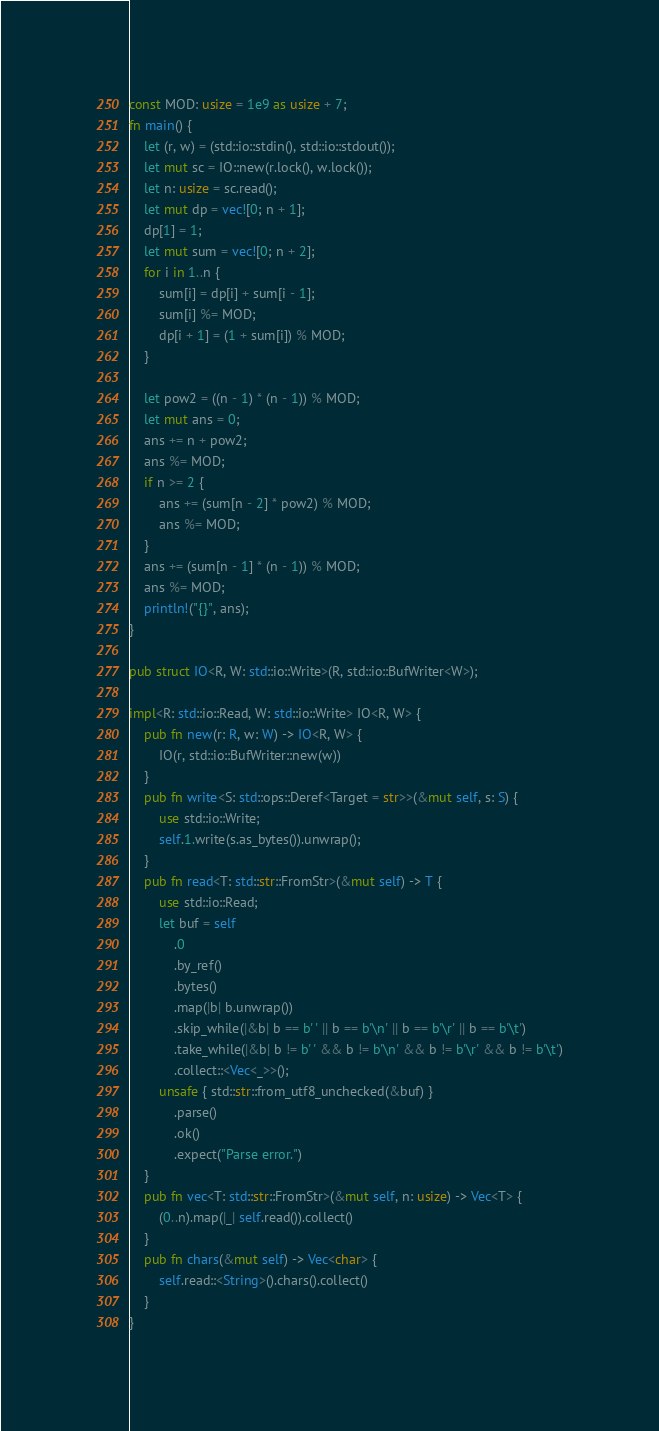<code> <loc_0><loc_0><loc_500><loc_500><_Rust_>const MOD: usize = 1e9 as usize + 7;
fn main() {
    let (r, w) = (std::io::stdin(), std::io::stdout());
    let mut sc = IO::new(r.lock(), w.lock());
    let n: usize = sc.read();
    let mut dp = vec![0; n + 1];
    dp[1] = 1;
    let mut sum = vec![0; n + 2];
    for i in 1..n {
        sum[i] = dp[i] + sum[i - 1];
        sum[i] %= MOD;
        dp[i + 1] = (1 + sum[i]) % MOD;
    }

    let pow2 = ((n - 1) * (n - 1)) % MOD;
    let mut ans = 0;
    ans += n + pow2;
    ans %= MOD;
    if n >= 2 {
        ans += (sum[n - 2] * pow2) % MOD;
        ans %= MOD;
    }
    ans += (sum[n - 1] * (n - 1)) % MOD;
    ans %= MOD;
    println!("{}", ans);
}

pub struct IO<R, W: std::io::Write>(R, std::io::BufWriter<W>);

impl<R: std::io::Read, W: std::io::Write> IO<R, W> {
    pub fn new(r: R, w: W) -> IO<R, W> {
        IO(r, std::io::BufWriter::new(w))
    }
    pub fn write<S: std::ops::Deref<Target = str>>(&mut self, s: S) {
        use std::io::Write;
        self.1.write(s.as_bytes()).unwrap();
    }
    pub fn read<T: std::str::FromStr>(&mut self) -> T {
        use std::io::Read;
        let buf = self
            .0
            .by_ref()
            .bytes()
            .map(|b| b.unwrap())
            .skip_while(|&b| b == b' ' || b == b'\n' || b == b'\r' || b == b'\t')
            .take_while(|&b| b != b' ' && b != b'\n' && b != b'\r' && b != b'\t')
            .collect::<Vec<_>>();
        unsafe { std::str::from_utf8_unchecked(&buf) }
            .parse()
            .ok()
            .expect("Parse error.")
    }
    pub fn vec<T: std::str::FromStr>(&mut self, n: usize) -> Vec<T> {
        (0..n).map(|_| self.read()).collect()
    }
    pub fn chars(&mut self) -> Vec<char> {
        self.read::<String>().chars().collect()
    }
}
</code> 